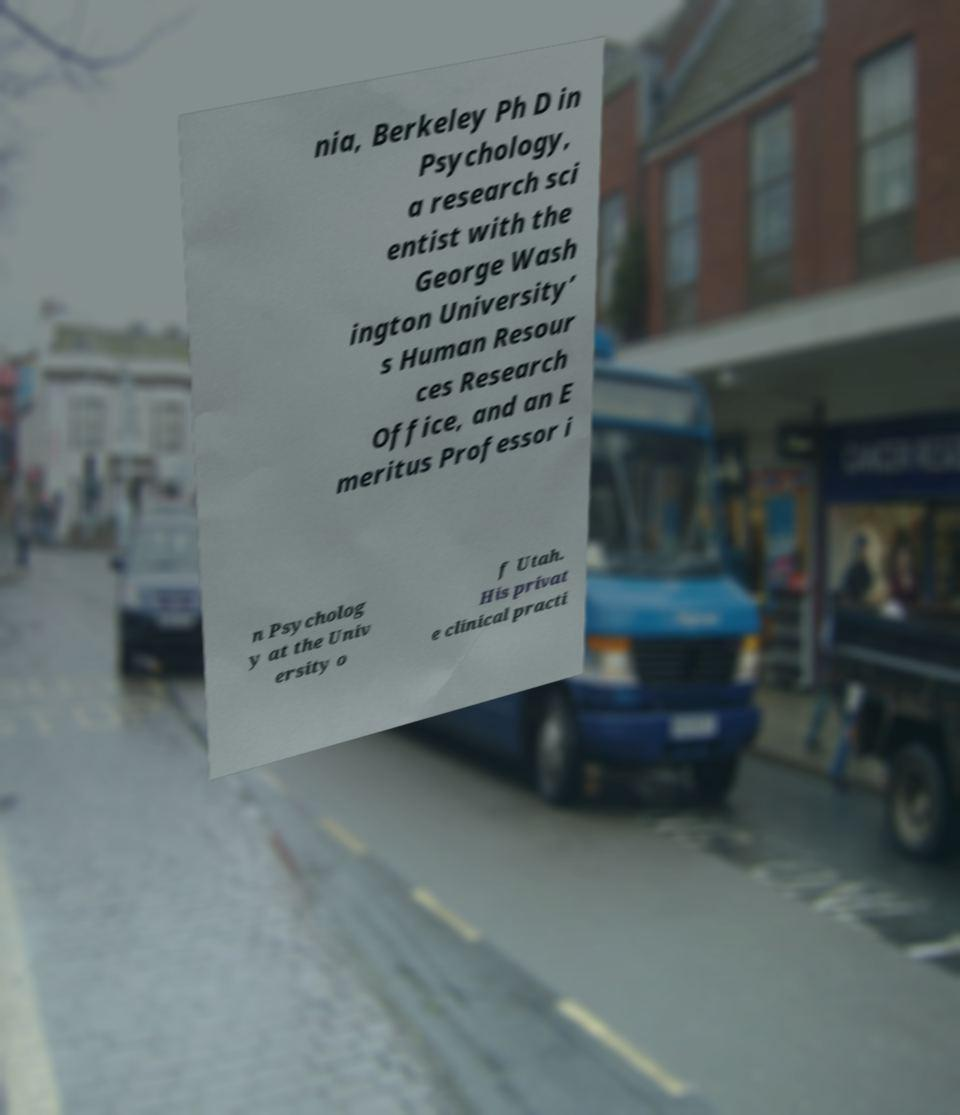Could you extract and type out the text from this image? nia, Berkeley Ph D in Psychology, a research sci entist with the George Wash ington University’ s Human Resour ces Research Office, and an E meritus Professor i n Psycholog y at the Univ ersity o f Utah. His privat e clinical practi 